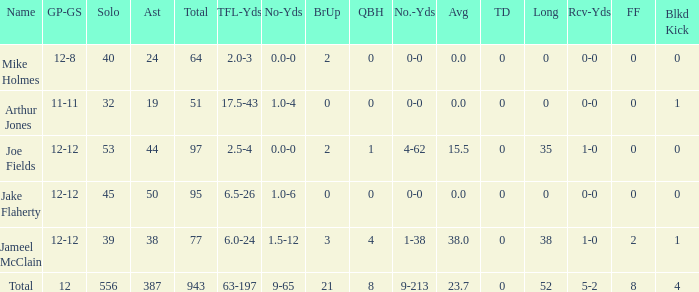How many players named jake flaherty? 1.0. 